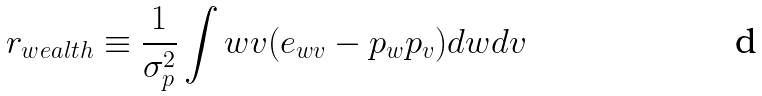Convert formula to latex. <formula><loc_0><loc_0><loc_500><loc_500>r _ { w e a l t h } \equiv \frac { 1 } { \sigma _ { p } ^ { 2 } } \int w v ( e _ { w v } - p _ { w } p _ { v } ) d w d v</formula> 